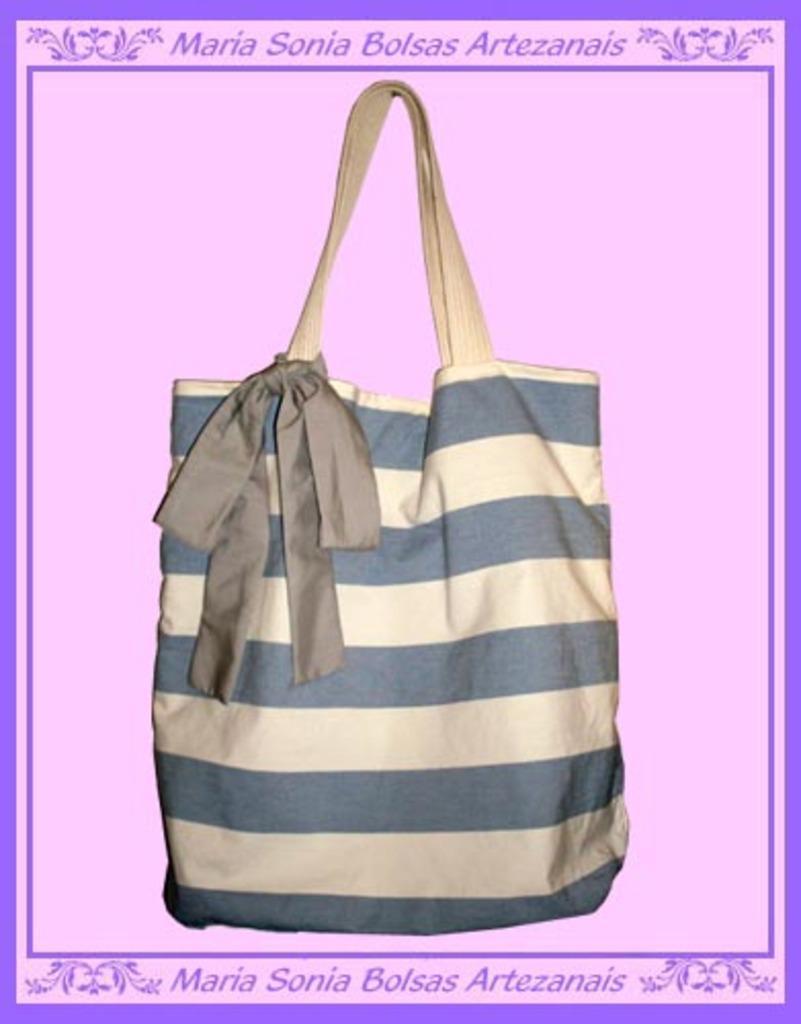How would you summarize this image in a sentence or two? There is a bag in this given picture on which some striped design was present. There is a pink color background here. 